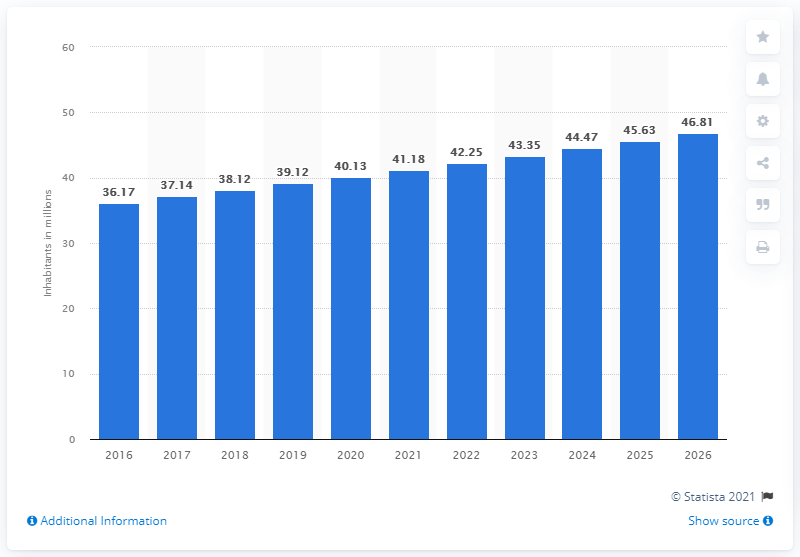Can you provide more information about the source of this data? The source of the data is indicated as 'Statista 2021' in the image. Statista is a reputable provider of market and consumer data. Detailed information, such as methodology or specific datasets, may be available directly from their platform or publications. 